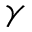<formula> <loc_0><loc_0><loc_500><loc_500>\gamma</formula> 